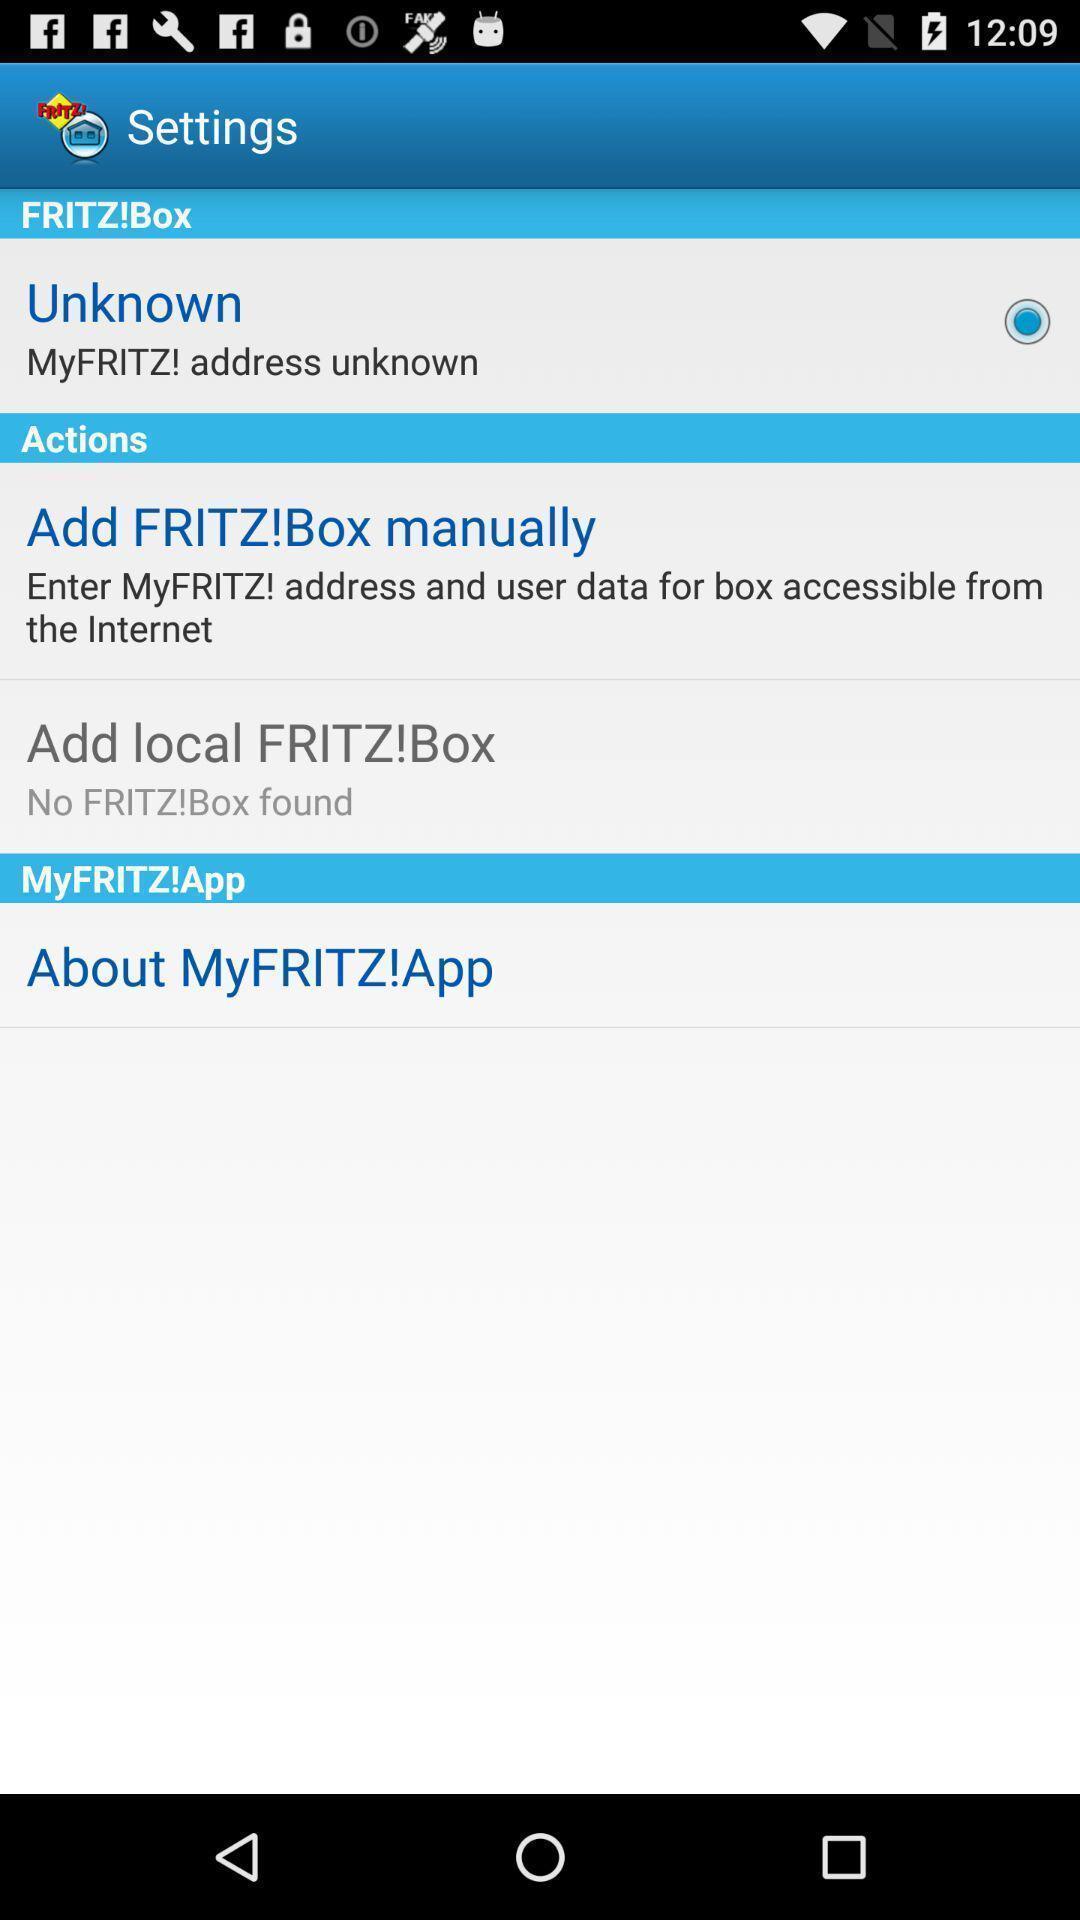Provide a textual representation of this image. Settings page for a remote network accessibility app. 